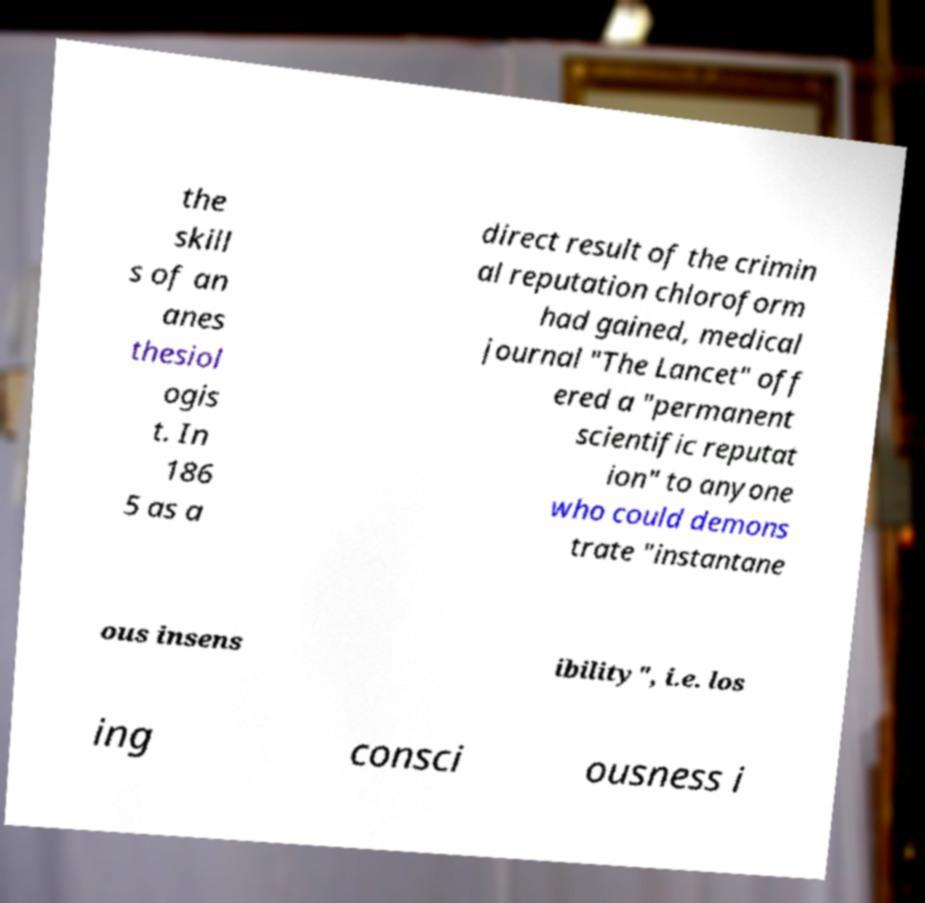For documentation purposes, I need the text within this image transcribed. Could you provide that? the skill s of an anes thesiol ogis t. In 186 5 as a direct result of the crimin al reputation chloroform had gained, medical journal "The Lancet" off ered a "permanent scientific reputat ion" to anyone who could demons trate "instantane ous insens ibility", i.e. los ing consci ousness i 